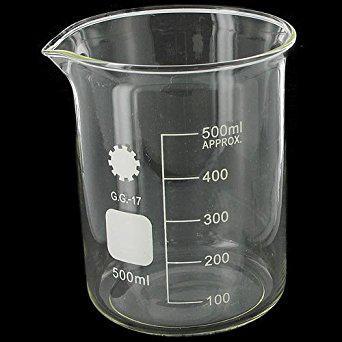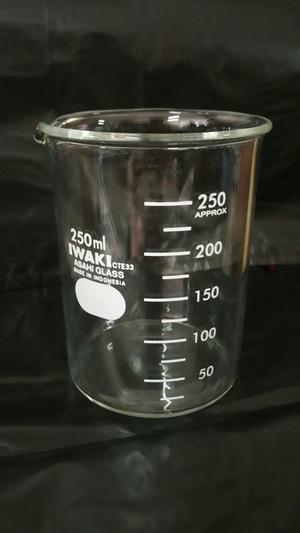The first image is the image on the left, the second image is the image on the right. Assess this claim about the two images: "There are just two beakers, and they are both on a dark background.". Correct or not? Answer yes or no. Yes. 